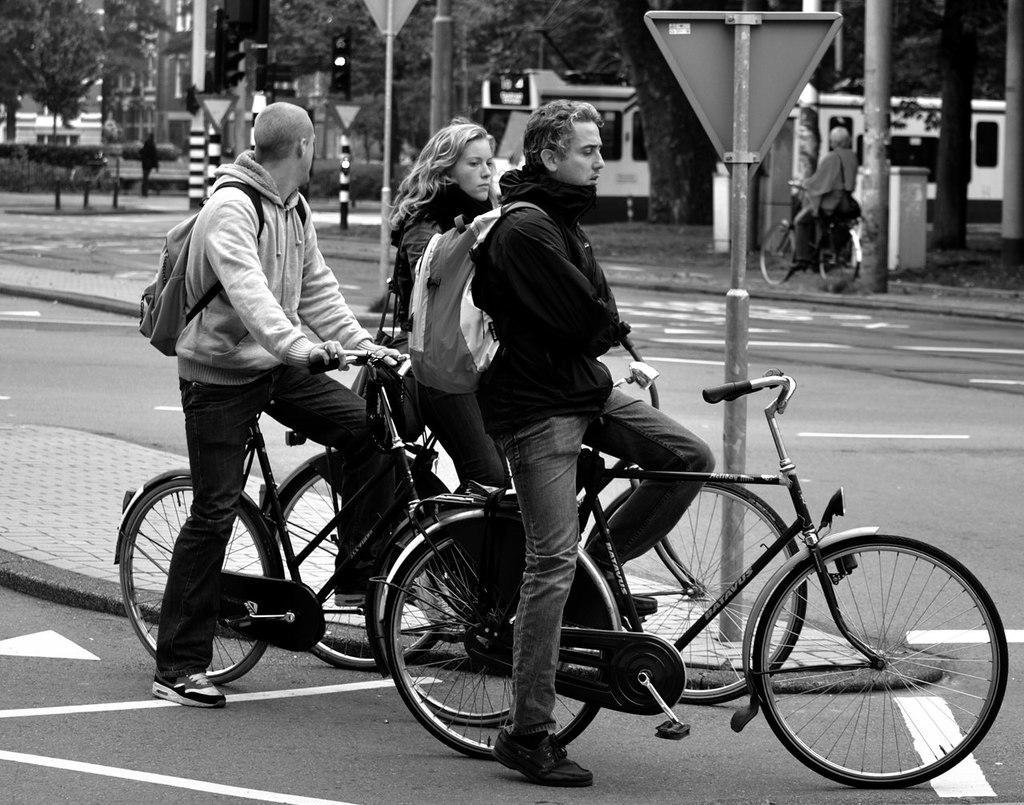Describe this image in one or two sentences. In the middle of the image few people are standing on the bicycle. Behind them there are few traffic poles. At the top of the image there are some trees. Top left side of the image there is a building. 